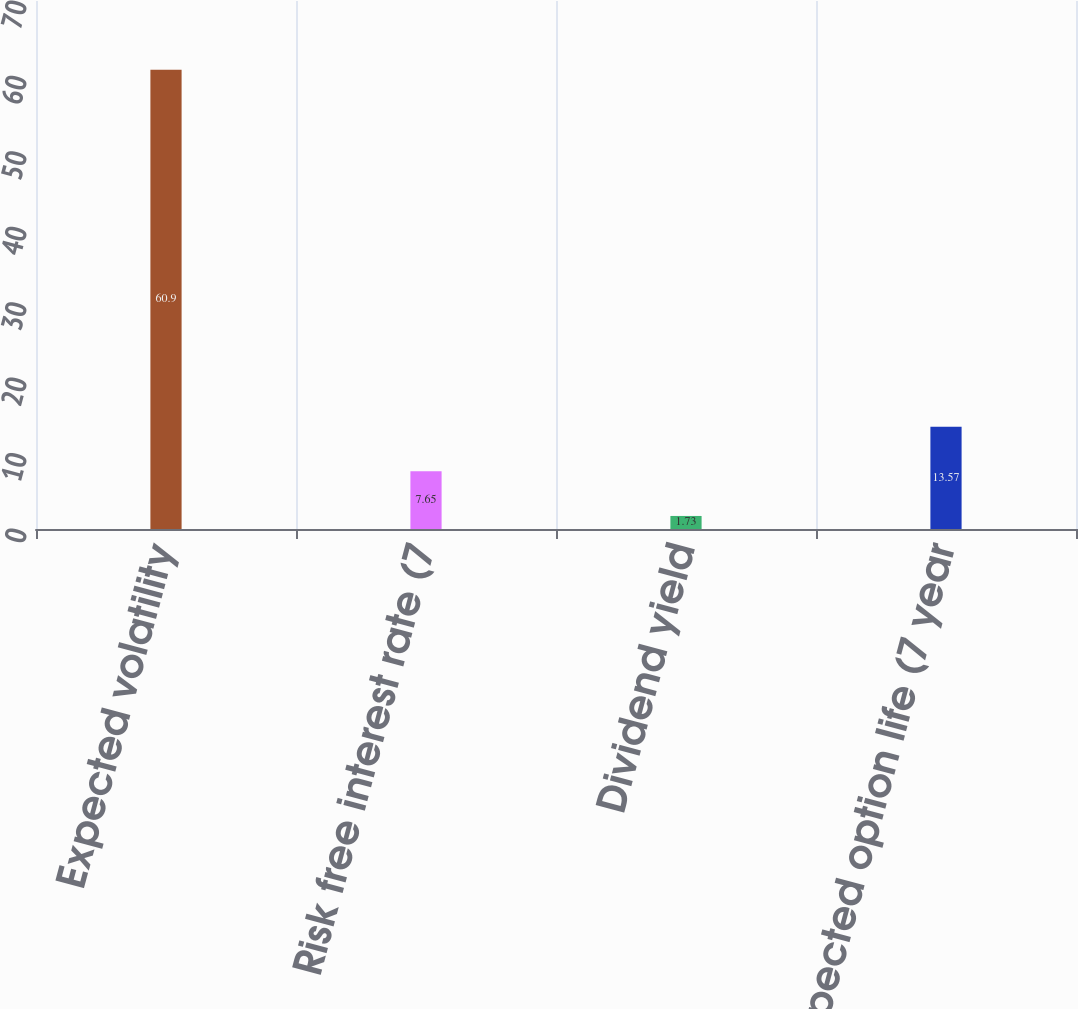Convert chart. <chart><loc_0><loc_0><loc_500><loc_500><bar_chart><fcel>Expected volatility<fcel>Risk free interest rate (7<fcel>Dividend yield<fcel>Expected option life (7 year<nl><fcel>60.9<fcel>7.65<fcel>1.73<fcel>13.57<nl></chart> 